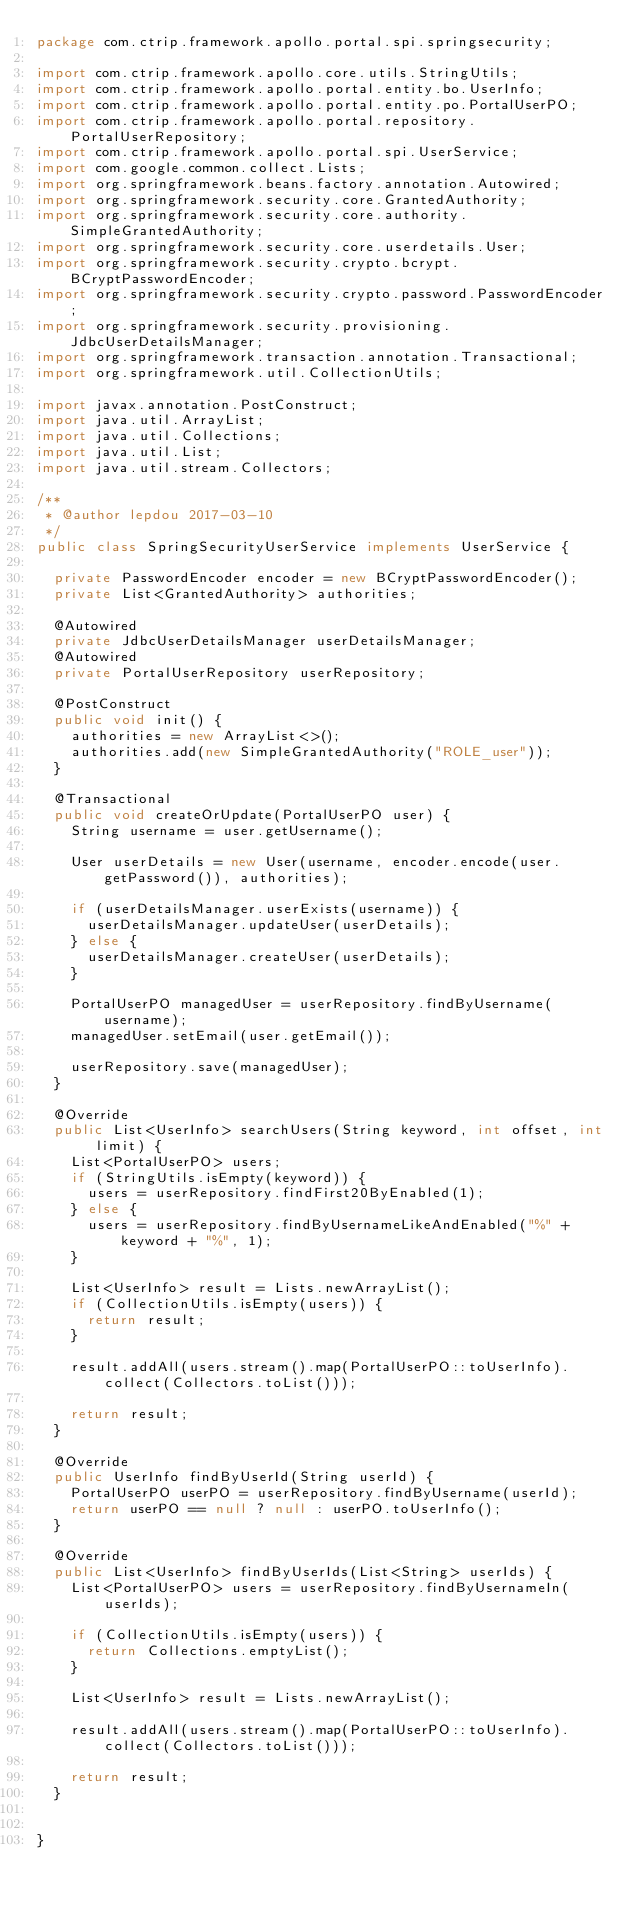Convert code to text. <code><loc_0><loc_0><loc_500><loc_500><_Java_>package com.ctrip.framework.apollo.portal.spi.springsecurity;

import com.ctrip.framework.apollo.core.utils.StringUtils;
import com.ctrip.framework.apollo.portal.entity.bo.UserInfo;
import com.ctrip.framework.apollo.portal.entity.po.PortalUserPO;
import com.ctrip.framework.apollo.portal.repository.PortalUserRepository;
import com.ctrip.framework.apollo.portal.spi.UserService;
import com.google.common.collect.Lists;
import org.springframework.beans.factory.annotation.Autowired;
import org.springframework.security.core.GrantedAuthority;
import org.springframework.security.core.authority.SimpleGrantedAuthority;
import org.springframework.security.core.userdetails.User;
import org.springframework.security.crypto.bcrypt.BCryptPasswordEncoder;
import org.springframework.security.crypto.password.PasswordEncoder;
import org.springframework.security.provisioning.JdbcUserDetailsManager;
import org.springframework.transaction.annotation.Transactional;
import org.springframework.util.CollectionUtils;

import javax.annotation.PostConstruct;
import java.util.ArrayList;
import java.util.Collections;
import java.util.List;
import java.util.stream.Collectors;

/**
 * @author lepdou 2017-03-10
 */
public class SpringSecurityUserService implements UserService {

  private PasswordEncoder encoder = new BCryptPasswordEncoder();
  private List<GrantedAuthority> authorities;

  @Autowired
  private JdbcUserDetailsManager userDetailsManager;
  @Autowired
  private PortalUserRepository userRepository;

  @PostConstruct
  public void init() {
    authorities = new ArrayList<>();
    authorities.add(new SimpleGrantedAuthority("ROLE_user"));
  }

  @Transactional
  public void createOrUpdate(PortalUserPO user) {
    String username = user.getUsername();

    User userDetails = new User(username, encoder.encode(user.getPassword()), authorities);

    if (userDetailsManager.userExists(username)) {
      userDetailsManager.updateUser(userDetails);
    } else {
      userDetailsManager.createUser(userDetails);
    }

    PortalUserPO managedUser = userRepository.findByUsername(username);
    managedUser.setEmail(user.getEmail());

    userRepository.save(managedUser);
  }

  @Override
  public List<UserInfo> searchUsers(String keyword, int offset, int limit) {
    List<PortalUserPO> users;
    if (StringUtils.isEmpty(keyword)) {
      users = userRepository.findFirst20ByEnabled(1);
    } else {
      users = userRepository.findByUsernameLikeAndEnabled("%" + keyword + "%", 1);
    }

    List<UserInfo> result = Lists.newArrayList();
    if (CollectionUtils.isEmpty(users)) {
      return result;
    }

    result.addAll(users.stream().map(PortalUserPO::toUserInfo).collect(Collectors.toList()));

    return result;
  }

  @Override
  public UserInfo findByUserId(String userId) {
    PortalUserPO userPO = userRepository.findByUsername(userId);
    return userPO == null ? null : userPO.toUserInfo();
  }

  @Override
  public List<UserInfo> findByUserIds(List<String> userIds) {
    List<PortalUserPO> users = userRepository.findByUsernameIn(userIds);

    if (CollectionUtils.isEmpty(users)) {
      return Collections.emptyList();
    }

    List<UserInfo> result = Lists.newArrayList();

    result.addAll(users.stream().map(PortalUserPO::toUserInfo).collect(Collectors.toList()));

    return result;
  }


}
</code> 